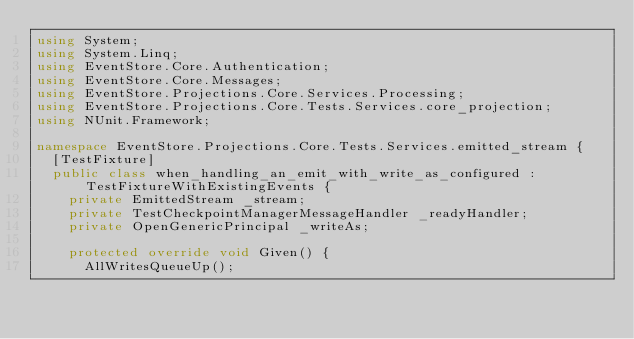<code> <loc_0><loc_0><loc_500><loc_500><_C#_>using System;
using System.Linq;
using EventStore.Core.Authentication;
using EventStore.Core.Messages;
using EventStore.Projections.Core.Services.Processing;
using EventStore.Projections.Core.Tests.Services.core_projection;
using NUnit.Framework;

namespace EventStore.Projections.Core.Tests.Services.emitted_stream {
	[TestFixture]
	public class when_handling_an_emit_with_write_as_configured : TestFixtureWithExistingEvents {
		private EmittedStream _stream;
		private TestCheckpointManagerMessageHandler _readyHandler;
		private OpenGenericPrincipal _writeAs;

		protected override void Given() {
			AllWritesQueueUp();</code> 